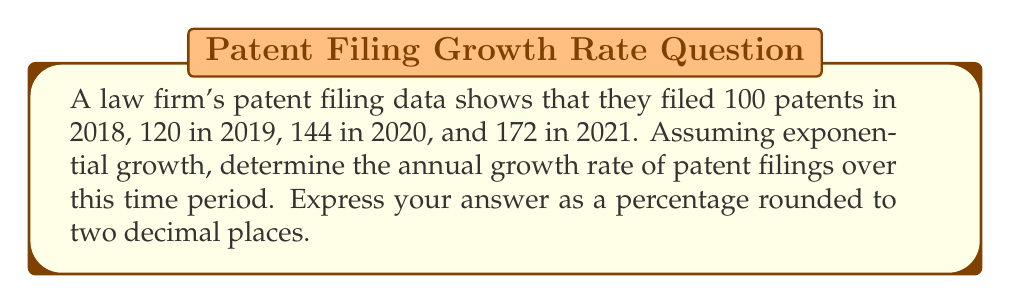Can you solve this math problem? To determine the annual growth rate assuming exponential growth, we can use the formula:

$$ A_n = A_0 \cdot (1 + r)^n $$

Where:
$A_n$ is the final value
$A_0$ is the initial value
$r$ is the annual growth rate
$n$ is the number of years

Let's solve this step-by-step:

1) We have $A_0 = 100$ (2018) and $A_3 = 172$ (2021), with $n = 3$ years.

2) Plugging these into our formula:

   $$ 172 = 100 \cdot (1 + r)^3 $$

3) Divide both sides by 100:

   $$ 1.72 = (1 + r)^3 $$

4) Take the cube root of both sides:

   $$ \sqrt[3]{1.72} = 1 + r $$

5) Subtract 1 from both sides:

   $$ \sqrt[3]{1.72} - 1 = r $$

6) Calculate:

   $$ r \approx 1.1984 - 1 = 0.1984 $$

7) Convert to percentage:

   $$ 0.1984 \times 100\% \approx 19.84\% $$

Thus, the annual growth rate is approximately 19.84%.
Answer: 19.84% 